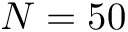<formula> <loc_0><loc_0><loc_500><loc_500>N = 5 0</formula> 